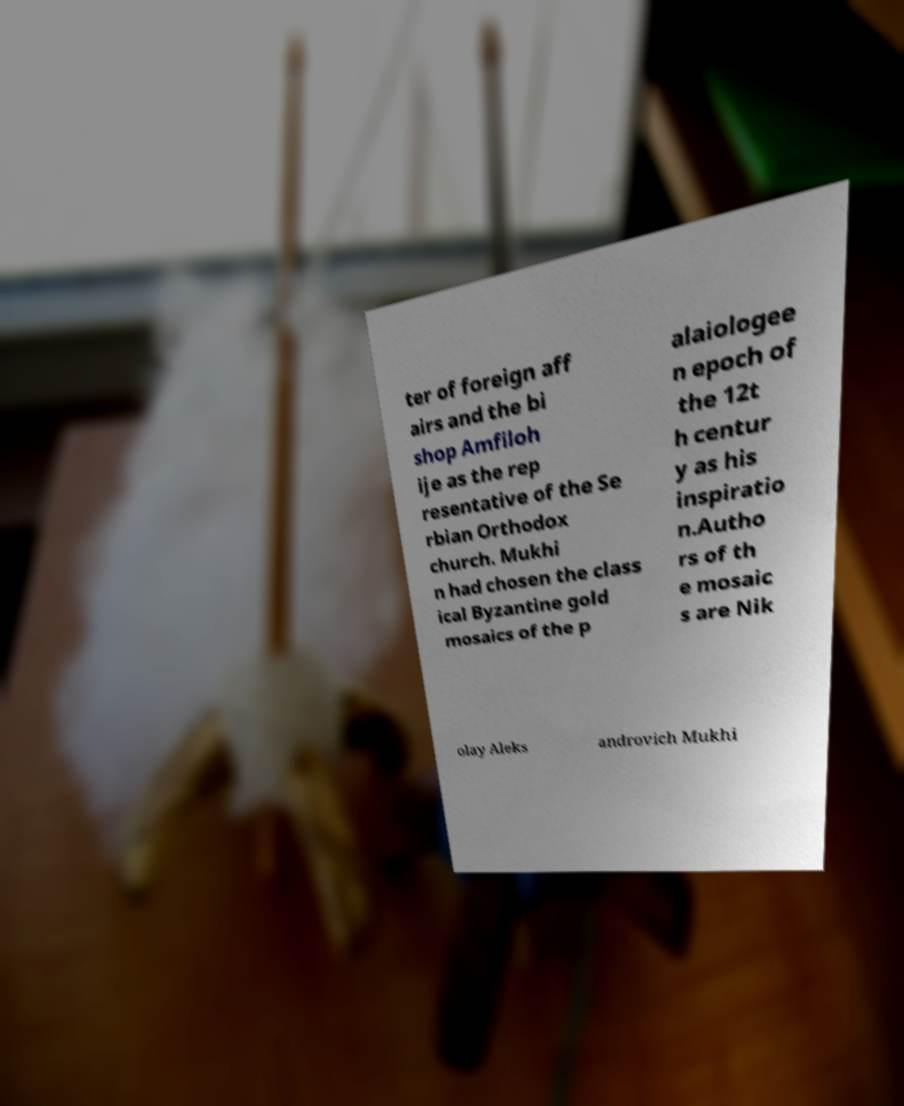I need the written content from this picture converted into text. Can you do that? ter of foreign aff airs and the bi shop Amfiloh ije as the rep resentative of the Se rbian Orthodox church. Mukhi n had chosen the class ical Byzantine gold mosaics of the p alaiologee n epoch of the 12t h centur y as his inspiratio n.Autho rs of th e mosaic s are Nik olay Aleks androvich Mukhi 